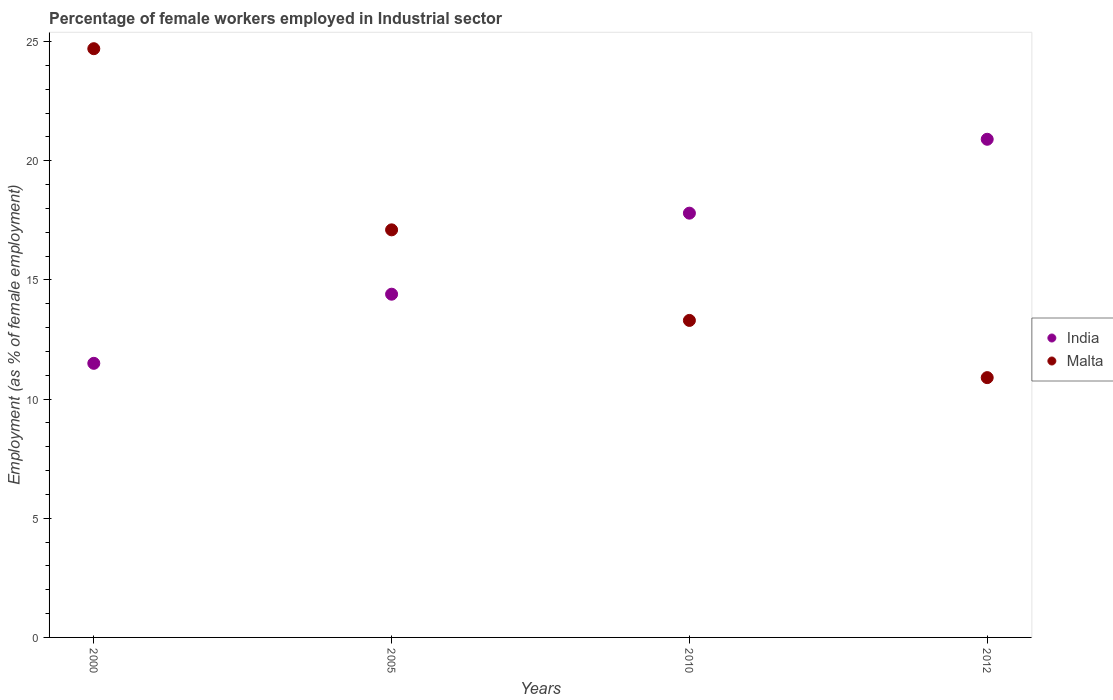What is the percentage of females employed in Industrial sector in India in 2005?
Offer a very short reply. 14.4. Across all years, what is the maximum percentage of females employed in Industrial sector in Malta?
Provide a succinct answer. 24.7. In which year was the percentage of females employed in Industrial sector in India minimum?
Your response must be concise. 2000. What is the total percentage of females employed in Industrial sector in Malta in the graph?
Your response must be concise. 66. What is the difference between the percentage of females employed in Industrial sector in India in 2005 and that in 2012?
Offer a terse response. -6.5. What is the difference between the percentage of females employed in Industrial sector in Malta in 2005 and the percentage of females employed in Industrial sector in India in 2010?
Provide a succinct answer. -0.7. What is the average percentage of females employed in Industrial sector in India per year?
Make the answer very short. 16.15. In the year 2005, what is the difference between the percentage of females employed in Industrial sector in India and percentage of females employed in Industrial sector in Malta?
Offer a very short reply. -2.7. What is the ratio of the percentage of females employed in Industrial sector in Malta in 2000 to that in 2010?
Your response must be concise. 1.86. Is the difference between the percentage of females employed in Industrial sector in India in 2000 and 2012 greater than the difference between the percentage of females employed in Industrial sector in Malta in 2000 and 2012?
Offer a very short reply. No. What is the difference between the highest and the second highest percentage of females employed in Industrial sector in India?
Your response must be concise. 3.1. What is the difference between the highest and the lowest percentage of females employed in Industrial sector in Malta?
Give a very brief answer. 13.8. Does the percentage of females employed in Industrial sector in India monotonically increase over the years?
Give a very brief answer. Yes. Is the percentage of females employed in Industrial sector in India strictly greater than the percentage of females employed in Industrial sector in Malta over the years?
Provide a short and direct response. No. Is the percentage of females employed in Industrial sector in Malta strictly less than the percentage of females employed in Industrial sector in India over the years?
Your response must be concise. No. How many dotlines are there?
Your response must be concise. 2. How many years are there in the graph?
Provide a succinct answer. 4. How many legend labels are there?
Give a very brief answer. 2. How are the legend labels stacked?
Ensure brevity in your answer.  Vertical. What is the title of the graph?
Your answer should be very brief. Percentage of female workers employed in Industrial sector. What is the label or title of the X-axis?
Give a very brief answer. Years. What is the label or title of the Y-axis?
Keep it short and to the point. Employment (as % of female employment). What is the Employment (as % of female employment) in India in 2000?
Your answer should be compact. 11.5. What is the Employment (as % of female employment) of Malta in 2000?
Offer a very short reply. 24.7. What is the Employment (as % of female employment) of India in 2005?
Provide a short and direct response. 14.4. What is the Employment (as % of female employment) of Malta in 2005?
Keep it short and to the point. 17.1. What is the Employment (as % of female employment) of India in 2010?
Make the answer very short. 17.8. What is the Employment (as % of female employment) in Malta in 2010?
Your response must be concise. 13.3. What is the Employment (as % of female employment) of India in 2012?
Provide a succinct answer. 20.9. What is the Employment (as % of female employment) in Malta in 2012?
Your answer should be compact. 10.9. Across all years, what is the maximum Employment (as % of female employment) in India?
Your response must be concise. 20.9. Across all years, what is the maximum Employment (as % of female employment) of Malta?
Offer a terse response. 24.7. Across all years, what is the minimum Employment (as % of female employment) of Malta?
Provide a short and direct response. 10.9. What is the total Employment (as % of female employment) of India in the graph?
Offer a terse response. 64.6. What is the difference between the Employment (as % of female employment) of Malta in 2000 and that in 2005?
Your answer should be compact. 7.6. What is the difference between the Employment (as % of female employment) of India in 2000 and that in 2012?
Ensure brevity in your answer.  -9.4. What is the difference between the Employment (as % of female employment) of India in 2005 and that in 2012?
Offer a very short reply. -6.5. What is the difference between the Employment (as % of female employment) of India in 2010 and that in 2012?
Give a very brief answer. -3.1. What is the difference between the Employment (as % of female employment) of Malta in 2010 and that in 2012?
Keep it short and to the point. 2.4. What is the difference between the Employment (as % of female employment) in India in 2000 and the Employment (as % of female employment) in Malta in 2005?
Offer a very short reply. -5.6. What is the difference between the Employment (as % of female employment) in India in 2000 and the Employment (as % of female employment) in Malta in 2010?
Your answer should be very brief. -1.8. What is the difference between the Employment (as % of female employment) of India in 2000 and the Employment (as % of female employment) of Malta in 2012?
Your response must be concise. 0.6. What is the difference between the Employment (as % of female employment) in India in 2005 and the Employment (as % of female employment) in Malta in 2012?
Make the answer very short. 3.5. What is the difference between the Employment (as % of female employment) in India in 2010 and the Employment (as % of female employment) in Malta in 2012?
Your answer should be compact. 6.9. What is the average Employment (as % of female employment) of India per year?
Make the answer very short. 16.15. What is the average Employment (as % of female employment) in Malta per year?
Offer a very short reply. 16.5. In the year 2000, what is the difference between the Employment (as % of female employment) in India and Employment (as % of female employment) in Malta?
Offer a very short reply. -13.2. In the year 2005, what is the difference between the Employment (as % of female employment) of India and Employment (as % of female employment) of Malta?
Ensure brevity in your answer.  -2.7. What is the ratio of the Employment (as % of female employment) of India in 2000 to that in 2005?
Offer a very short reply. 0.8. What is the ratio of the Employment (as % of female employment) of Malta in 2000 to that in 2005?
Offer a terse response. 1.44. What is the ratio of the Employment (as % of female employment) of India in 2000 to that in 2010?
Provide a short and direct response. 0.65. What is the ratio of the Employment (as % of female employment) of Malta in 2000 to that in 2010?
Ensure brevity in your answer.  1.86. What is the ratio of the Employment (as % of female employment) in India in 2000 to that in 2012?
Offer a very short reply. 0.55. What is the ratio of the Employment (as % of female employment) in Malta in 2000 to that in 2012?
Make the answer very short. 2.27. What is the ratio of the Employment (as % of female employment) in India in 2005 to that in 2010?
Ensure brevity in your answer.  0.81. What is the ratio of the Employment (as % of female employment) in Malta in 2005 to that in 2010?
Provide a succinct answer. 1.29. What is the ratio of the Employment (as % of female employment) in India in 2005 to that in 2012?
Your response must be concise. 0.69. What is the ratio of the Employment (as % of female employment) of Malta in 2005 to that in 2012?
Provide a short and direct response. 1.57. What is the ratio of the Employment (as % of female employment) in India in 2010 to that in 2012?
Offer a very short reply. 0.85. What is the ratio of the Employment (as % of female employment) of Malta in 2010 to that in 2012?
Keep it short and to the point. 1.22. What is the difference between the highest and the second highest Employment (as % of female employment) in India?
Your answer should be compact. 3.1. What is the difference between the highest and the lowest Employment (as % of female employment) of India?
Your answer should be very brief. 9.4. 